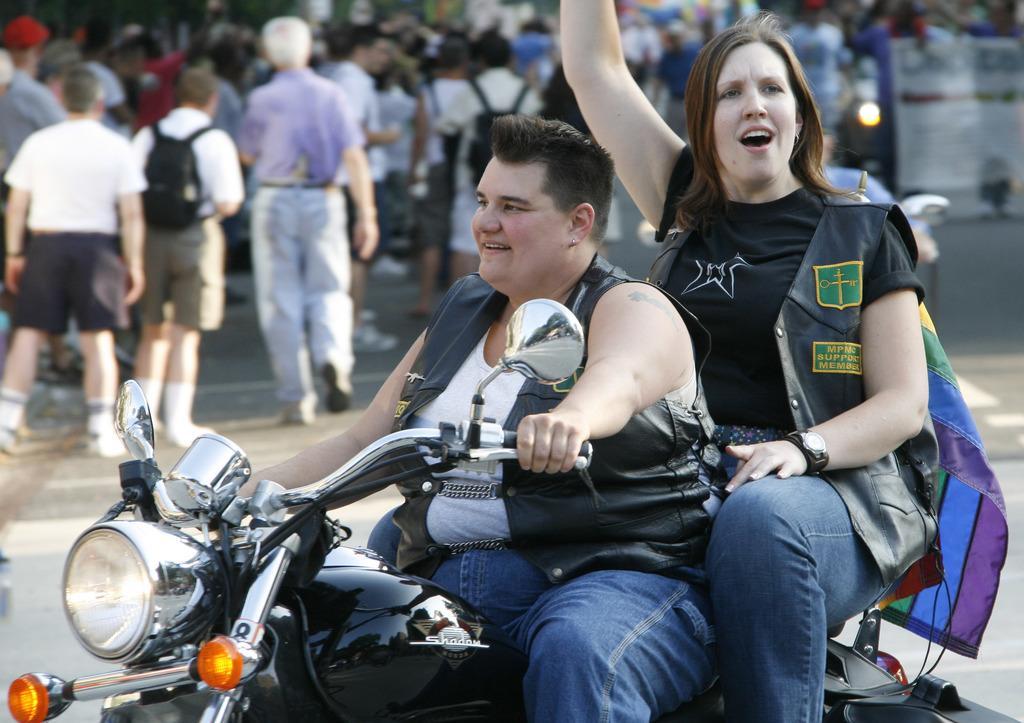Could you give a brief overview of what you see in this image? There are two people in the image man and woman. Man is riding a bike and woman is sitting beside man. Woman is also wearing a watch which is in black color. In background we can see a group of people who are walking on road. On left side we can see a man wearing a bag and walking. 